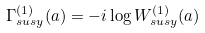Convert formula to latex. <formula><loc_0><loc_0><loc_500><loc_500>\Gamma _ { s u s y } ^ { ( 1 ) } ( a ) = - i \log W _ { s u s y } ^ { ( 1 ) } ( a )</formula> 